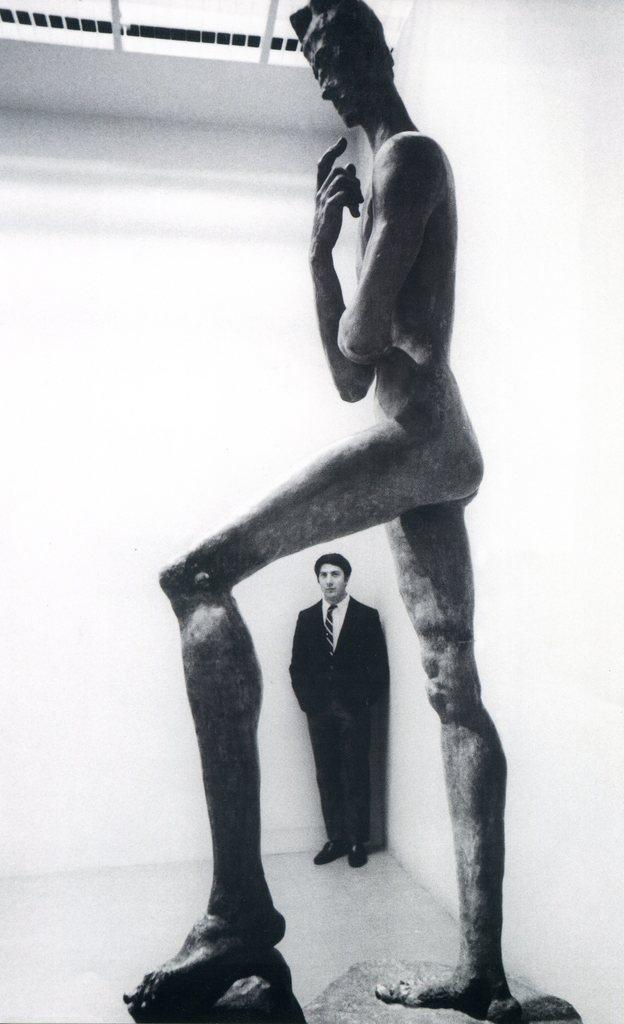What is the main subject in the center of the image? There is a sculpture in the center of the image. What else can be seen in the background of the image? There is a man standing in the background of the image, and he is wearing a suit. What is the man standing near in the background? The man is standing near a wall in the background. How many ladybugs are crawling on the sculpture in the image? There are no ladybugs present on the sculpture in the image. What type of butter is being used to create the sculpture in the image? The sculpture is not made of butter; it is a solid structure. 